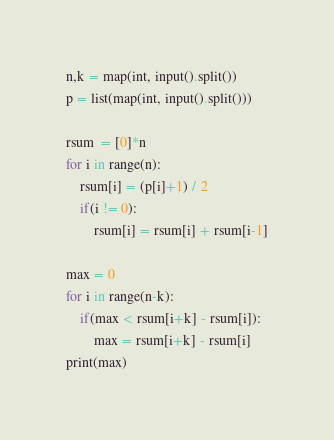<code> <loc_0><loc_0><loc_500><loc_500><_Python_>n,k = map(int, input().split())
p = list(map(int, input().split()))

rsum  = [0]*n
for i in range(n):
    rsum[i] = (p[i]+1) / 2
    if(i != 0):
        rsum[i] = rsum[i] + rsum[i-1]

max = 0
for i in range(n-k):
    if(max < rsum[i+k] - rsum[i]):
        max = rsum[i+k] - rsum[i]
print(max)</code> 